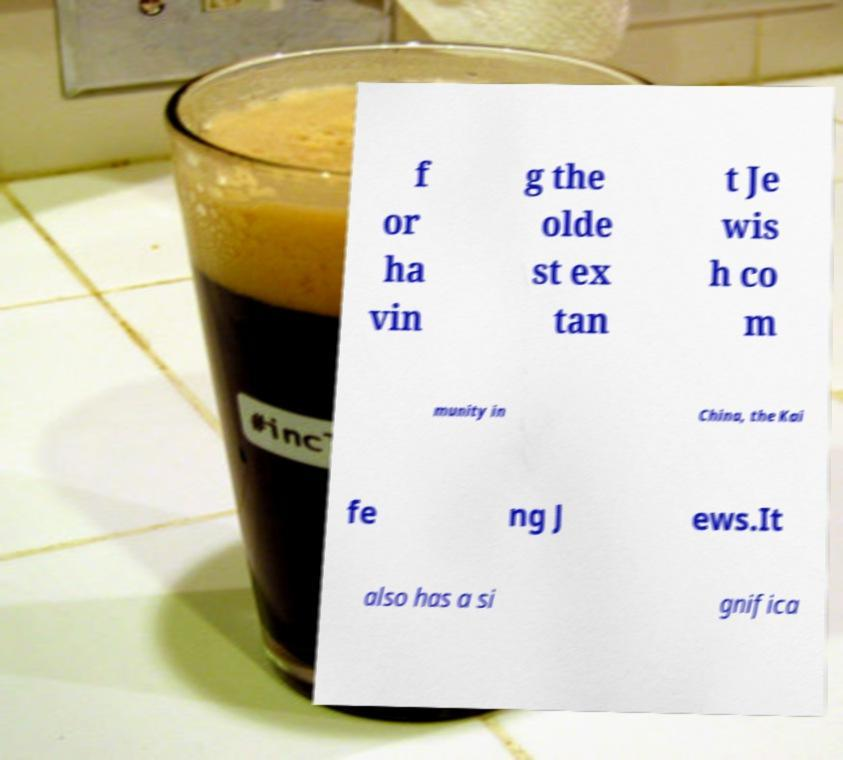Could you extract and type out the text from this image? f or ha vin g the olde st ex tan t Je wis h co m munity in China, the Kai fe ng J ews.It also has a si gnifica 